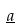Convert formula to latex. <formula><loc_0><loc_0><loc_500><loc_500>\underline { a }</formula> 